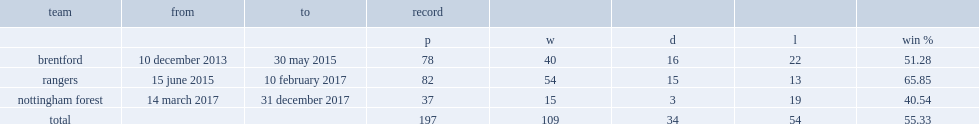What was the winning pecentage of brentford? 51.28. 